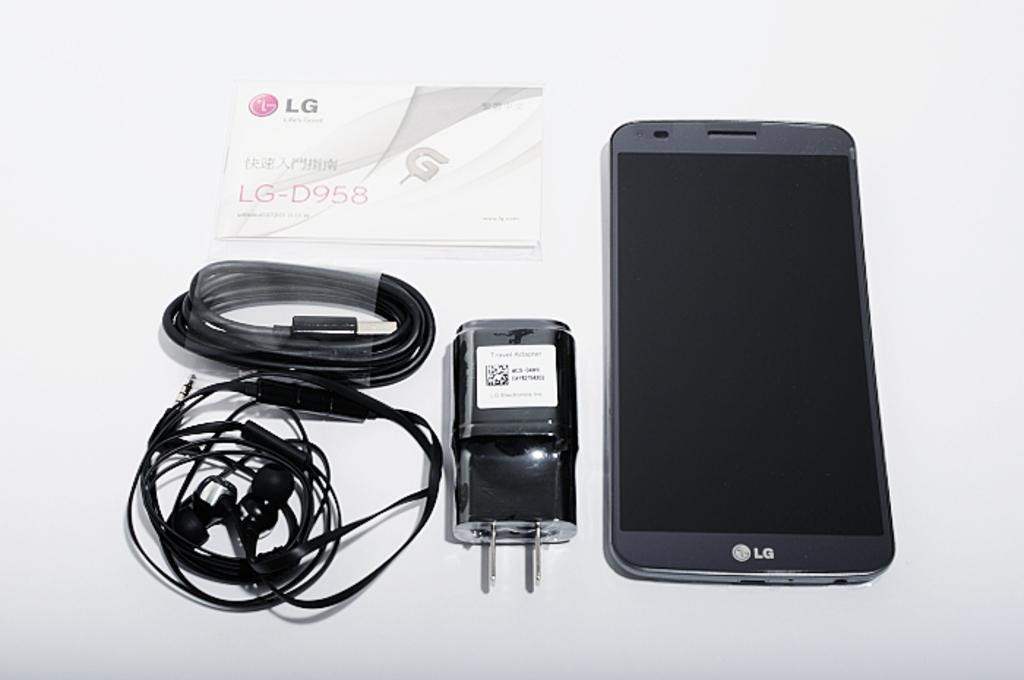<image>
Offer a succinct explanation of the picture presented. An LG smarphone next to the typical contents of what it's packaged with. 